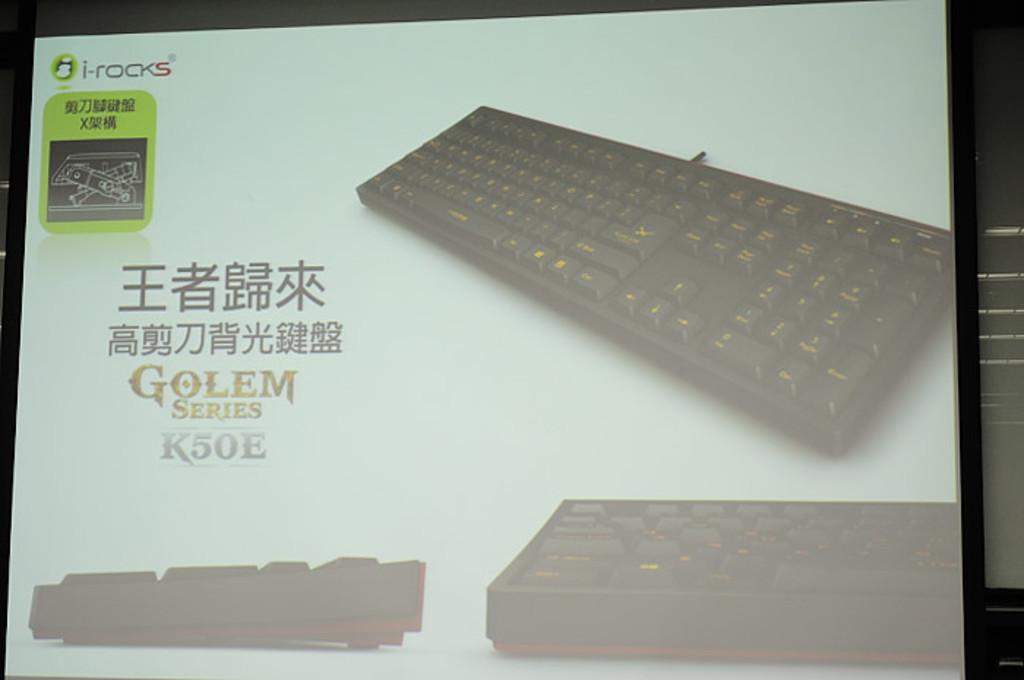What brand of keyboard is this?
Your answer should be compact. I-rocks. 